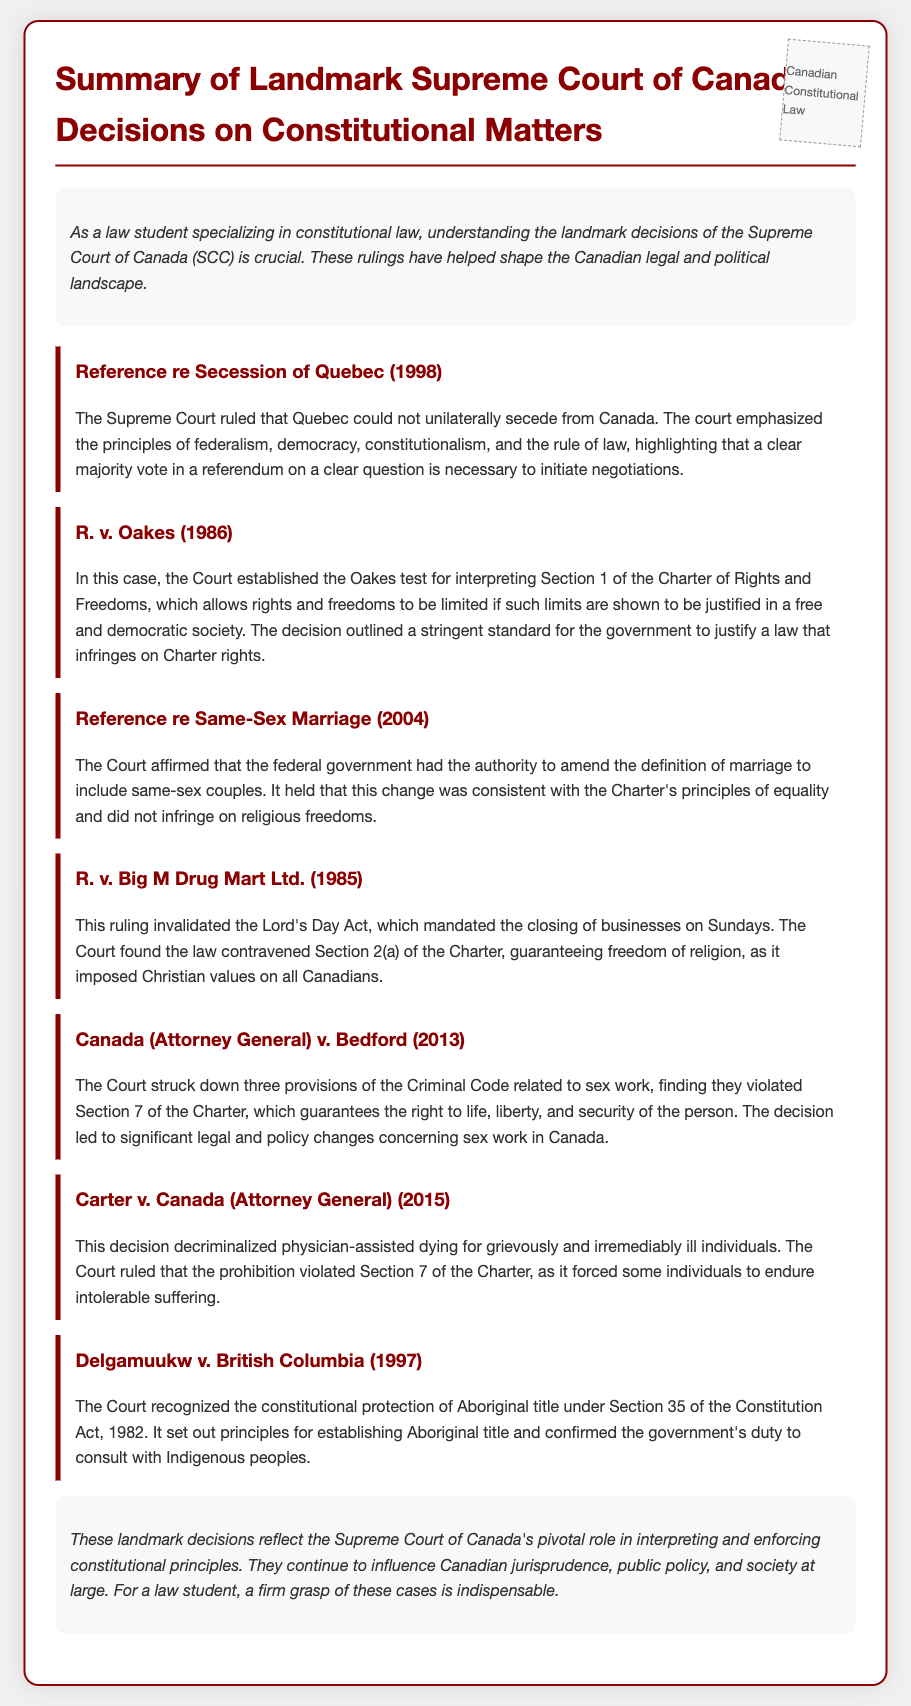What is the title of the document? The title is clearly stated at the top of the document.
Answer: Summary of Landmark Supreme Court of Canada Decisions on Constitutional Matters What case established the Oakes test? This information can be found in the description of the relevant landmark case.
Answer: R. v. Oakes (1986) In what year was the Reference re Secession of Quebec decided? The year is mentioned directly in the case title.
Answer: 1998 Which case involved the decriminalization of physician-assisted dying? The document specifies the implications of a specific Supreme Court decision regarding physician-assisted dying.
Answer: Carter v. Canada (Attorney General) (2015) What was ruled unconstitutional in R. v. Big M Drug Mart Ltd.? This detail is noted within the summary of the case.
Answer: Lord's Day Act Which case recognized constitutional protection of Aboriginal title? This information is highlighted in the summary of the relevant landmark ruling.
Answer: Delgamuukw v. British Columbia (1997) What principle was emphasized in the Reference re Same-Sex Marriage? The summary focuses on the constitutional principle applied in the decision regarding marriage.
Answer: Equality How many landmark cases are summarized in the document? The number of cases is indicated by counting the cases listed in the document.
Answer: Seven What does Section 1 of the Charter of Rights and Freedoms pertain to? This information is derived from the context of the Oakes test mentioned in the document.
Answer: Limitations on rights and freedoms 